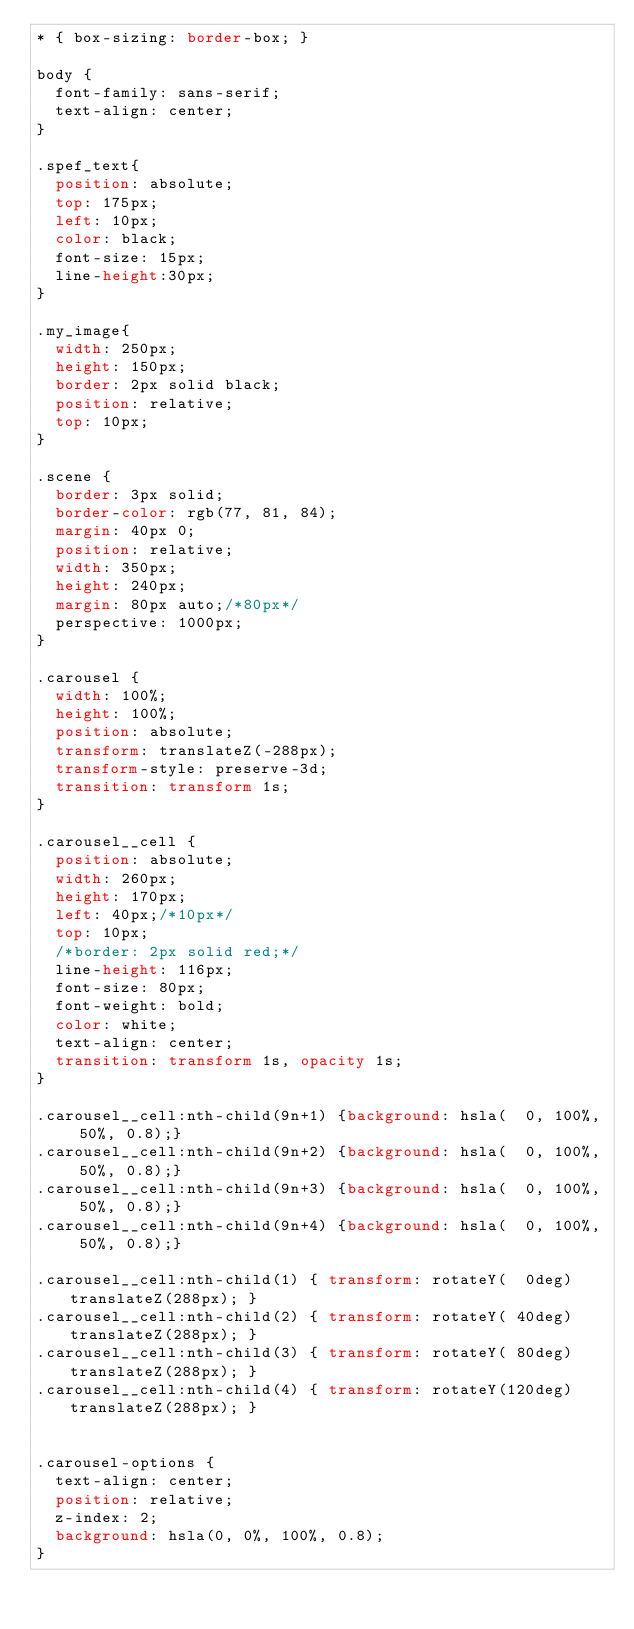<code> <loc_0><loc_0><loc_500><loc_500><_CSS_>* { box-sizing: border-box; }

body {
  font-family: sans-serif;
  text-align: center;
}

.spef_text{
  position: absolute;
  top: 175px;
  left: 10px;
  color: black;
  font-size: 15px;
  line-height:30px;
}

.my_image{
  width: 250px;
  height: 150px;
  border: 2px solid black;
  position: relative;
  top: 10px;
}

.scene {
  border: 3px solid;
  border-color: rgb(77, 81, 84);
  margin: 40px 0;
  position: relative;
  width: 350px;
  height: 240px;
  margin: 80px auto;/*80px*/
  perspective: 1000px;
}

.carousel {
  width: 100%;
  height: 100%;
  position: absolute;
  transform: translateZ(-288px);
  transform-style: preserve-3d;
  transition: transform 1s;
}

.carousel__cell {
  position: absolute;
  width: 260px;
  height: 170px;
  left: 40px;/*10px*/
  top: 10px;
  /*border: 2px solid red;*/
  line-height: 116px;
  font-size: 80px;
  font-weight: bold;
  color: white;
  text-align: center;
  transition: transform 1s, opacity 1s;
}

.carousel__cell:nth-child(9n+1) {background: hsla(  0, 100%, 50%, 0.8);}
.carousel__cell:nth-child(9n+2) {background: hsla(  0, 100%, 50%, 0.8);}
.carousel__cell:nth-child(9n+3) {background: hsla(  0, 100%, 50%, 0.8);}
.carousel__cell:nth-child(9n+4) {background: hsla(  0, 100%, 50%, 0.8);}

.carousel__cell:nth-child(1) { transform: rotateY(  0deg) translateZ(288px); }
.carousel__cell:nth-child(2) { transform: rotateY( 40deg) translateZ(288px); }
.carousel__cell:nth-child(3) { transform: rotateY( 80deg) translateZ(288px); }
.carousel__cell:nth-child(4) { transform: rotateY(120deg) translateZ(288px); }


.carousel-options {
  text-align: center;
  position: relative;
  z-index: 2;
  background: hsla(0, 0%, 100%, 0.8);
}
</code> 